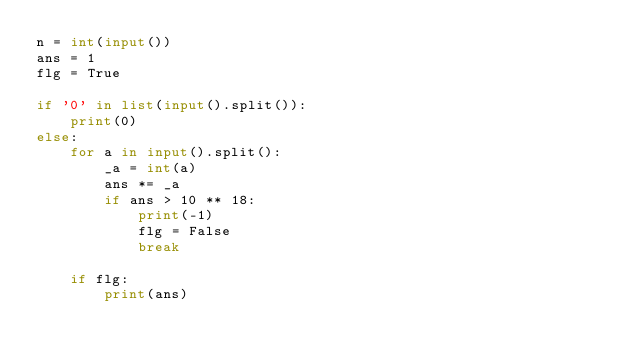Convert code to text. <code><loc_0><loc_0><loc_500><loc_500><_Python_>n = int(input())
ans = 1
flg = True

if '0' in list(input().split()):
    print(0)
else:
    for a in input().split():
        _a = int(a)
        ans *= _a
        if ans > 10 ** 18:
            print(-1)
            flg = False
            break

    if flg:
        print(ans)
</code> 